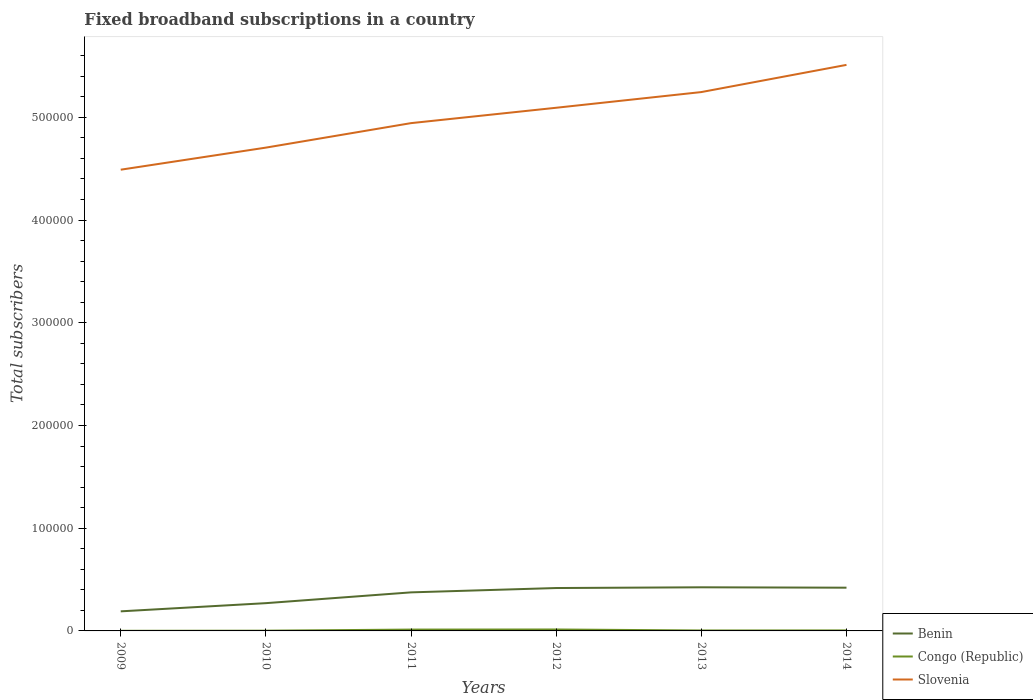Does the line corresponding to Slovenia intersect with the line corresponding to Benin?
Offer a terse response. No. Is the number of lines equal to the number of legend labels?
Provide a succinct answer. Yes. Across all years, what is the maximum number of broadband subscriptions in Slovenia?
Offer a terse response. 4.49e+05. What is the total number of broadband subscriptions in Slovenia in the graph?
Give a very brief answer. -4.18e+04. What is the difference between the highest and the second highest number of broadband subscriptions in Congo (Republic)?
Ensure brevity in your answer.  1267. Is the number of broadband subscriptions in Slovenia strictly greater than the number of broadband subscriptions in Congo (Republic) over the years?
Your answer should be compact. No. How many lines are there?
Your response must be concise. 3. What is the difference between two consecutive major ticks on the Y-axis?
Your response must be concise. 1.00e+05. Does the graph contain any zero values?
Make the answer very short. No. Does the graph contain grids?
Ensure brevity in your answer.  No. Where does the legend appear in the graph?
Offer a terse response. Bottom right. What is the title of the graph?
Your answer should be compact. Fixed broadband subscriptions in a country. What is the label or title of the X-axis?
Provide a succinct answer. Years. What is the label or title of the Y-axis?
Make the answer very short. Total subscribers. What is the Total subscribers in Benin in 2009?
Your answer should be compact. 1.91e+04. What is the Total subscribers in Congo (Republic) in 2009?
Provide a succinct answer. 125. What is the Total subscribers in Slovenia in 2009?
Provide a succinct answer. 4.49e+05. What is the Total subscribers in Benin in 2010?
Ensure brevity in your answer.  2.70e+04. What is the Total subscribers in Congo (Republic) in 2010?
Ensure brevity in your answer.  250. What is the Total subscribers in Slovenia in 2010?
Give a very brief answer. 4.71e+05. What is the Total subscribers of Benin in 2011?
Provide a succinct answer. 3.75e+04. What is the Total subscribers of Congo (Republic) in 2011?
Provide a short and direct response. 1311. What is the Total subscribers of Slovenia in 2011?
Ensure brevity in your answer.  4.94e+05. What is the Total subscribers of Benin in 2012?
Your response must be concise. 4.18e+04. What is the Total subscribers of Congo (Republic) in 2012?
Your answer should be compact. 1392. What is the Total subscribers of Slovenia in 2012?
Provide a short and direct response. 5.09e+05. What is the Total subscribers of Benin in 2013?
Give a very brief answer. 4.25e+04. What is the Total subscribers of Congo (Republic) in 2013?
Give a very brief answer. 438. What is the Total subscribers in Slovenia in 2013?
Provide a short and direct response. 5.25e+05. What is the Total subscribers in Benin in 2014?
Offer a terse response. 4.21e+04. What is the Total subscribers in Congo (Republic) in 2014?
Provide a short and direct response. 500. What is the Total subscribers of Slovenia in 2014?
Offer a very short reply. 5.51e+05. Across all years, what is the maximum Total subscribers of Benin?
Offer a very short reply. 4.25e+04. Across all years, what is the maximum Total subscribers of Congo (Republic)?
Offer a terse response. 1392. Across all years, what is the maximum Total subscribers of Slovenia?
Your answer should be very brief. 5.51e+05. Across all years, what is the minimum Total subscribers of Benin?
Give a very brief answer. 1.91e+04. Across all years, what is the minimum Total subscribers in Congo (Republic)?
Ensure brevity in your answer.  125. Across all years, what is the minimum Total subscribers of Slovenia?
Your response must be concise. 4.49e+05. What is the total Total subscribers of Benin in the graph?
Your answer should be compact. 2.10e+05. What is the total Total subscribers of Congo (Republic) in the graph?
Your answer should be very brief. 4016. What is the total Total subscribers in Slovenia in the graph?
Your answer should be compact. 3.00e+06. What is the difference between the Total subscribers of Benin in 2009 and that in 2010?
Offer a terse response. -7973. What is the difference between the Total subscribers in Congo (Republic) in 2009 and that in 2010?
Provide a succinct answer. -125. What is the difference between the Total subscribers in Slovenia in 2009 and that in 2010?
Provide a short and direct response. -2.15e+04. What is the difference between the Total subscribers of Benin in 2009 and that in 2011?
Make the answer very short. -1.85e+04. What is the difference between the Total subscribers of Congo (Republic) in 2009 and that in 2011?
Make the answer very short. -1186. What is the difference between the Total subscribers in Slovenia in 2009 and that in 2011?
Your response must be concise. -4.53e+04. What is the difference between the Total subscribers in Benin in 2009 and that in 2012?
Make the answer very short. -2.27e+04. What is the difference between the Total subscribers in Congo (Republic) in 2009 and that in 2012?
Your answer should be very brief. -1267. What is the difference between the Total subscribers of Slovenia in 2009 and that in 2012?
Your response must be concise. -6.03e+04. What is the difference between the Total subscribers of Benin in 2009 and that in 2013?
Your answer should be very brief. -2.34e+04. What is the difference between the Total subscribers of Congo (Republic) in 2009 and that in 2013?
Make the answer very short. -313. What is the difference between the Total subscribers of Slovenia in 2009 and that in 2013?
Keep it short and to the point. -7.56e+04. What is the difference between the Total subscribers in Benin in 2009 and that in 2014?
Your answer should be very brief. -2.30e+04. What is the difference between the Total subscribers in Congo (Republic) in 2009 and that in 2014?
Make the answer very short. -375. What is the difference between the Total subscribers in Slovenia in 2009 and that in 2014?
Keep it short and to the point. -1.02e+05. What is the difference between the Total subscribers of Benin in 2010 and that in 2011?
Offer a terse response. -1.05e+04. What is the difference between the Total subscribers in Congo (Republic) in 2010 and that in 2011?
Give a very brief answer. -1061. What is the difference between the Total subscribers of Slovenia in 2010 and that in 2011?
Keep it short and to the point. -2.38e+04. What is the difference between the Total subscribers of Benin in 2010 and that in 2012?
Your answer should be compact. -1.47e+04. What is the difference between the Total subscribers of Congo (Republic) in 2010 and that in 2012?
Provide a succinct answer. -1142. What is the difference between the Total subscribers of Slovenia in 2010 and that in 2012?
Offer a very short reply. -3.88e+04. What is the difference between the Total subscribers of Benin in 2010 and that in 2013?
Provide a succinct answer. -1.54e+04. What is the difference between the Total subscribers of Congo (Republic) in 2010 and that in 2013?
Provide a short and direct response. -188. What is the difference between the Total subscribers of Slovenia in 2010 and that in 2013?
Your answer should be compact. -5.41e+04. What is the difference between the Total subscribers in Benin in 2010 and that in 2014?
Make the answer very short. -1.51e+04. What is the difference between the Total subscribers in Congo (Republic) in 2010 and that in 2014?
Your answer should be very brief. -250. What is the difference between the Total subscribers in Slovenia in 2010 and that in 2014?
Provide a succinct answer. -8.06e+04. What is the difference between the Total subscribers in Benin in 2011 and that in 2012?
Offer a terse response. -4226. What is the difference between the Total subscribers of Congo (Republic) in 2011 and that in 2012?
Offer a very short reply. -81. What is the difference between the Total subscribers in Slovenia in 2011 and that in 2012?
Provide a short and direct response. -1.50e+04. What is the difference between the Total subscribers in Benin in 2011 and that in 2013?
Make the answer very short. -4942. What is the difference between the Total subscribers of Congo (Republic) in 2011 and that in 2013?
Keep it short and to the point. 873. What is the difference between the Total subscribers in Slovenia in 2011 and that in 2013?
Give a very brief answer. -3.02e+04. What is the difference between the Total subscribers in Benin in 2011 and that in 2014?
Your answer should be compact. -4552. What is the difference between the Total subscribers of Congo (Republic) in 2011 and that in 2014?
Give a very brief answer. 811. What is the difference between the Total subscribers in Slovenia in 2011 and that in 2014?
Offer a very short reply. -5.67e+04. What is the difference between the Total subscribers in Benin in 2012 and that in 2013?
Ensure brevity in your answer.  -716. What is the difference between the Total subscribers of Congo (Republic) in 2012 and that in 2013?
Give a very brief answer. 954. What is the difference between the Total subscribers in Slovenia in 2012 and that in 2013?
Keep it short and to the point. -1.53e+04. What is the difference between the Total subscribers of Benin in 2012 and that in 2014?
Make the answer very short. -326. What is the difference between the Total subscribers in Congo (Republic) in 2012 and that in 2014?
Keep it short and to the point. 892. What is the difference between the Total subscribers in Slovenia in 2012 and that in 2014?
Provide a succinct answer. -4.18e+04. What is the difference between the Total subscribers of Benin in 2013 and that in 2014?
Your response must be concise. 390. What is the difference between the Total subscribers in Congo (Republic) in 2013 and that in 2014?
Offer a terse response. -62. What is the difference between the Total subscribers of Slovenia in 2013 and that in 2014?
Ensure brevity in your answer.  -2.65e+04. What is the difference between the Total subscribers in Benin in 2009 and the Total subscribers in Congo (Republic) in 2010?
Your response must be concise. 1.88e+04. What is the difference between the Total subscribers in Benin in 2009 and the Total subscribers in Slovenia in 2010?
Provide a succinct answer. -4.51e+05. What is the difference between the Total subscribers of Congo (Republic) in 2009 and the Total subscribers of Slovenia in 2010?
Give a very brief answer. -4.70e+05. What is the difference between the Total subscribers in Benin in 2009 and the Total subscribers in Congo (Republic) in 2011?
Ensure brevity in your answer.  1.78e+04. What is the difference between the Total subscribers in Benin in 2009 and the Total subscribers in Slovenia in 2011?
Give a very brief answer. -4.75e+05. What is the difference between the Total subscribers in Congo (Republic) in 2009 and the Total subscribers in Slovenia in 2011?
Your answer should be compact. -4.94e+05. What is the difference between the Total subscribers of Benin in 2009 and the Total subscribers of Congo (Republic) in 2012?
Ensure brevity in your answer.  1.77e+04. What is the difference between the Total subscribers in Benin in 2009 and the Total subscribers in Slovenia in 2012?
Offer a very short reply. -4.90e+05. What is the difference between the Total subscribers in Congo (Republic) in 2009 and the Total subscribers in Slovenia in 2012?
Your response must be concise. -5.09e+05. What is the difference between the Total subscribers in Benin in 2009 and the Total subscribers in Congo (Republic) in 2013?
Offer a terse response. 1.86e+04. What is the difference between the Total subscribers of Benin in 2009 and the Total subscribers of Slovenia in 2013?
Your answer should be compact. -5.06e+05. What is the difference between the Total subscribers of Congo (Republic) in 2009 and the Total subscribers of Slovenia in 2013?
Make the answer very short. -5.24e+05. What is the difference between the Total subscribers of Benin in 2009 and the Total subscribers of Congo (Republic) in 2014?
Give a very brief answer. 1.86e+04. What is the difference between the Total subscribers of Benin in 2009 and the Total subscribers of Slovenia in 2014?
Offer a very short reply. -5.32e+05. What is the difference between the Total subscribers of Congo (Republic) in 2009 and the Total subscribers of Slovenia in 2014?
Your response must be concise. -5.51e+05. What is the difference between the Total subscribers in Benin in 2010 and the Total subscribers in Congo (Republic) in 2011?
Provide a succinct answer. 2.57e+04. What is the difference between the Total subscribers of Benin in 2010 and the Total subscribers of Slovenia in 2011?
Ensure brevity in your answer.  -4.67e+05. What is the difference between the Total subscribers of Congo (Republic) in 2010 and the Total subscribers of Slovenia in 2011?
Provide a succinct answer. -4.94e+05. What is the difference between the Total subscribers of Benin in 2010 and the Total subscribers of Congo (Republic) in 2012?
Give a very brief answer. 2.56e+04. What is the difference between the Total subscribers in Benin in 2010 and the Total subscribers in Slovenia in 2012?
Give a very brief answer. -4.82e+05. What is the difference between the Total subscribers in Congo (Republic) in 2010 and the Total subscribers in Slovenia in 2012?
Your answer should be very brief. -5.09e+05. What is the difference between the Total subscribers in Benin in 2010 and the Total subscribers in Congo (Republic) in 2013?
Ensure brevity in your answer.  2.66e+04. What is the difference between the Total subscribers in Benin in 2010 and the Total subscribers in Slovenia in 2013?
Provide a succinct answer. -4.98e+05. What is the difference between the Total subscribers in Congo (Republic) in 2010 and the Total subscribers in Slovenia in 2013?
Your response must be concise. -5.24e+05. What is the difference between the Total subscribers in Benin in 2010 and the Total subscribers in Congo (Republic) in 2014?
Offer a very short reply. 2.65e+04. What is the difference between the Total subscribers of Benin in 2010 and the Total subscribers of Slovenia in 2014?
Your answer should be very brief. -5.24e+05. What is the difference between the Total subscribers in Congo (Republic) in 2010 and the Total subscribers in Slovenia in 2014?
Ensure brevity in your answer.  -5.51e+05. What is the difference between the Total subscribers in Benin in 2011 and the Total subscribers in Congo (Republic) in 2012?
Your answer should be very brief. 3.61e+04. What is the difference between the Total subscribers of Benin in 2011 and the Total subscribers of Slovenia in 2012?
Keep it short and to the point. -4.72e+05. What is the difference between the Total subscribers of Congo (Republic) in 2011 and the Total subscribers of Slovenia in 2012?
Make the answer very short. -5.08e+05. What is the difference between the Total subscribers of Benin in 2011 and the Total subscribers of Congo (Republic) in 2013?
Your response must be concise. 3.71e+04. What is the difference between the Total subscribers of Benin in 2011 and the Total subscribers of Slovenia in 2013?
Make the answer very short. -4.87e+05. What is the difference between the Total subscribers of Congo (Republic) in 2011 and the Total subscribers of Slovenia in 2013?
Offer a terse response. -5.23e+05. What is the difference between the Total subscribers of Benin in 2011 and the Total subscribers of Congo (Republic) in 2014?
Your response must be concise. 3.70e+04. What is the difference between the Total subscribers in Benin in 2011 and the Total subscribers in Slovenia in 2014?
Make the answer very short. -5.14e+05. What is the difference between the Total subscribers in Congo (Republic) in 2011 and the Total subscribers in Slovenia in 2014?
Offer a very short reply. -5.50e+05. What is the difference between the Total subscribers of Benin in 2012 and the Total subscribers of Congo (Republic) in 2013?
Your answer should be compact. 4.13e+04. What is the difference between the Total subscribers in Benin in 2012 and the Total subscribers in Slovenia in 2013?
Offer a terse response. -4.83e+05. What is the difference between the Total subscribers of Congo (Republic) in 2012 and the Total subscribers of Slovenia in 2013?
Your response must be concise. -5.23e+05. What is the difference between the Total subscribers in Benin in 2012 and the Total subscribers in Congo (Republic) in 2014?
Make the answer very short. 4.13e+04. What is the difference between the Total subscribers in Benin in 2012 and the Total subscribers in Slovenia in 2014?
Offer a very short reply. -5.09e+05. What is the difference between the Total subscribers in Congo (Republic) in 2012 and the Total subscribers in Slovenia in 2014?
Give a very brief answer. -5.50e+05. What is the difference between the Total subscribers of Benin in 2013 and the Total subscribers of Congo (Republic) in 2014?
Your answer should be very brief. 4.20e+04. What is the difference between the Total subscribers in Benin in 2013 and the Total subscribers in Slovenia in 2014?
Give a very brief answer. -5.09e+05. What is the difference between the Total subscribers in Congo (Republic) in 2013 and the Total subscribers in Slovenia in 2014?
Your answer should be very brief. -5.51e+05. What is the average Total subscribers of Benin per year?
Offer a very short reply. 3.50e+04. What is the average Total subscribers of Congo (Republic) per year?
Offer a terse response. 669.33. What is the average Total subscribers in Slovenia per year?
Offer a terse response. 5.00e+05. In the year 2009, what is the difference between the Total subscribers in Benin and Total subscribers in Congo (Republic)?
Offer a very short reply. 1.89e+04. In the year 2009, what is the difference between the Total subscribers in Benin and Total subscribers in Slovenia?
Your response must be concise. -4.30e+05. In the year 2009, what is the difference between the Total subscribers of Congo (Republic) and Total subscribers of Slovenia?
Give a very brief answer. -4.49e+05. In the year 2010, what is the difference between the Total subscribers of Benin and Total subscribers of Congo (Republic)?
Your response must be concise. 2.68e+04. In the year 2010, what is the difference between the Total subscribers in Benin and Total subscribers in Slovenia?
Your answer should be compact. -4.43e+05. In the year 2010, what is the difference between the Total subscribers of Congo (Republic) and Total subscribers of Slovenia?
Offer a terse response. -4.70e+05. In the year 2011, what is the difference between the Total subscribers in Benin and Total subscribers in Congo (Republic)?
Your response must be concise. 3.62e+04. In the year 2011, what is the difference between the Total subscribers in Benin and Total subscribers in Slovenia?
Make the answer very short. -4.57e+05. In the year 2011, what is the difference between the Total subscribers of Congo (Republic) and Total subscribers of Slovenia?
Offer a terse response. -4.93e+05. In the year 2012, what is the difference between the Total subscribers in Benin and Total subscribers in Congo (Republic)?
Ensure brevity in your answer.  4.04e+04. In the year 2012, what is the difference between the Total subscribers in Benin and Total subscribers in Slovenia?
Give a very brief answer. -4.68e+05. In the year 2012, what is the difference between the Total subscribers in Congo (Republic) and Total subscribers in Slovenia?
Ensure brevity in your answer.  -5.08e+05. In the year 2013, what is the difference between the Total subscribers in Benin and Total subscribers in Congo (Republic)?
Your answer should be very brief. 4.20e+04. In the year 2013, what is the difference between the Total subscribers in Benin and Total subscribers in Slovenia?
Make the answer very short. -4.82e+05. In the year 2013, what is the difference between the Total subscribers in Congo (Republic) and Total subscribers in Slovenia?
Keep it short and to the point. -5.24e+05. In the year 2014, what is the difference between the Total subscribers of Benin and Total subscribers of Congo (Republic)?
Provide a succinct answer. 4.16e+04. In the year 2014, what is the difference between the Total subscribers of Benin and Total subscribers of Slovenia?
Ensure brevity in your answer.  -5.09e+05. In the year 2014, what is the difference between the Total subscribers of Congo (Republic) and Total subscribers of Slovenia?
Offer a terse response. -5.51e+05. What is the ratio of the Total subscribers in Benin in 2009 to that in 2010?
Keep it short and to the point. 0.71. What is the ratio of the Total subscribers of Slovenia in 2009 to that in 2010?
Offer a terse response. 0.95. What is the ratio of the Total subscribers in Benin in 2009 to that in 2011?
Keep it short and to the point. 0.51. What is the ratio of the Total subscribers in Congo (Republic) in 2009 to that in 2011?
Your answer should be compact. 0.1. What is the ratio of the Total subscribers in Slovenia in 2009 to that in 2011?
Your answer should be compact. 0.91. What is the ratio of the Total subscribers of Benin in 2009 to that in 2012?
Offer a terse response. 0.46. What is the ratio of the Total subscribers in Congo (Republic) in 2009 to that in 2012?
Your answer should be very brief. 0.09. What is the ratio of the Total subscribers in Slovenia in 2009 to that in 2012?
Provide a short and direct response. 0.88. What is the ratio of the Total subscribers in Benin in 2009 to that in 2013?
Your answer should be very brief. 0.45. What is the ratio of the Total subscribers in Congo (Republic) in 2009 to that in 2013?
Give a very brief answer. 0.29. What is the ratio of the Total subscribers in Slovenia in 2009 to that in 2013?
Offer a terse response. 0.86. What is the ratio of the Total subscribers of Benin in 2009 to that in 2014?
Your answer should be very brief. 0.45. What is the ratio of the Total subscribers of Congo (Republic) in 2009 to that in 2014?
Make the answer very short. 0.25. What is the ratio of the Total subscribers of Slovenia in 2009 to that in 2014?
Offer a terse response. 0.81. What is the ratio of the Total subscribers of Benin in 2010 to that in 2011?
Ensure brevity in your answer.  0.72. What is the ratio of the Total subscribers in Congo (Republic) in 2010 to that in 2011?
Provide a succinct answer. 0.19. What is the ratio of the Total subscribers in Slovenia in 2010 to that in 2011?
Your response must be concise. 0.95. What is the ratio of the Total subscribers in Benin in 2010 to that in 2012?
Make the answer very short. 0.65. What is the ratio of the Total subscribers of Congo (Republic) in 2010 to that in 2012?
Your answer should be compact. 0.18. What is the ratio of the Total subscribers of Slovenia in 2010 to that in 2012?
Offer a very short reply. 0.92. What is the ratio of the Total subscribers in Benin in 2010 to that in 2013?
Provide a succinct answer. 0.64. What is the ratio of the Total subscribers in Congo (Republic) in 2010 to that in 2013?
Offer a terse response. 0.57. What is the ratio of the Total subscribers of Slovenia in 2010 to that in 2013?
Make the answer very short. 0.9. What is the ratio of the Total subscribers of Benin in 2010 to that in 2014?
Your answer should be very brief. 0.64. What is the ratio of the Total subscribers of Slovenia in 2010 to that in 2014?
Ensure brevity in your answer.  0.85. What is the ratio of the Total subscribers of Benin in 2011 to that in 2012?
Your answer should be very brief. 0.9. What is the ratio of the Total subscribers in Congo (Republic) in 2011 to that in 2012?
Provide a succinct answer. 0.94. What is the ratio of the Total subscribers in Slovenia in 2011 to that in 2012?
Ensure brevity in your answer.  0.97. What is the ratio of the Total subscribers in Benin in 2011 to that in 2013?
Make the answer very short. 0.88. What is the ratio of the Total subscribers of Congo (Republic) in 2011 to that in 2013?
Offer a very short reply. 2.99. What is the ratio of the Total subscribers in Slovenia in 2011 to that in 2013?
Your response must be concise. 0.94. What is the ratio of the Total subscribers in Benin in 2011 to that in 2014?
Provide a short and direct response. 0.89. What is the ratio of the Total subscribers of Congo (Republic) in 2011 to that in 2014?
Offer a terse response. 2.62. What is the ratio of the Total subscribers of Slovenia in 2011 to that in 2014?
Offer a terse response. 0.9. What is the ratio of the Total subscribers of Benin in 2012 to that in 2013?
Ensure brevity in your answer.  0.98. What is the ratio of the Total subscribers in Congo (Republic) in 2012 to that in 2013?
Provide a short and direct response. 3.18. What is the ratio of the Total subscribers of Slovenia in 2012 to that in 2013?
Keep it short and to the point. 0.97. What is the ratio of the Total subscribers of Congo (Republic) in 2012 to that in 2014?
Provide a succinct answer. 2.78. What is the ratio of the Total subscribers in Slovenia in 2012 to that in 2014?
Your answer should be very brief. 0.92. What is the ratio of the Total subscribers in Benin in 2013 to that in 2014?
Offer a terse response. 1.01. What is the ratio of the Total subscribers in Congo (Republic) in 2013 to that in 2014?
Your answer should be compact. 0.88. What is the ratio of the Total subscribers of Slovenia in 2013 to that in 2014?
Provide a short and direct response. 0.95. What is the difference between the highest and the second highest Total subscribers of Benin?
Your answer should be compact. 390. What is the difference between the highest and the second highest Total subscribers of Congo (Republic)?
Make the answer very short. 81. What is the difference between the highest and the second highest Total subscribers in Slovenia?
Ensure brevity in your answer.  2.65e+04. What is the difference between the highest and the lowest Total subscribers of Benin?
Your answer should be compact. 2.34e+04. What is the difference between the highest and the lowest Total subscribers of Congo (Republic)?
Your answer should be compact. 1267. What is the difference between the highest and the lowest Total subscribers of Slovenia?
Provide a short and direct response. 1.02e+05. 